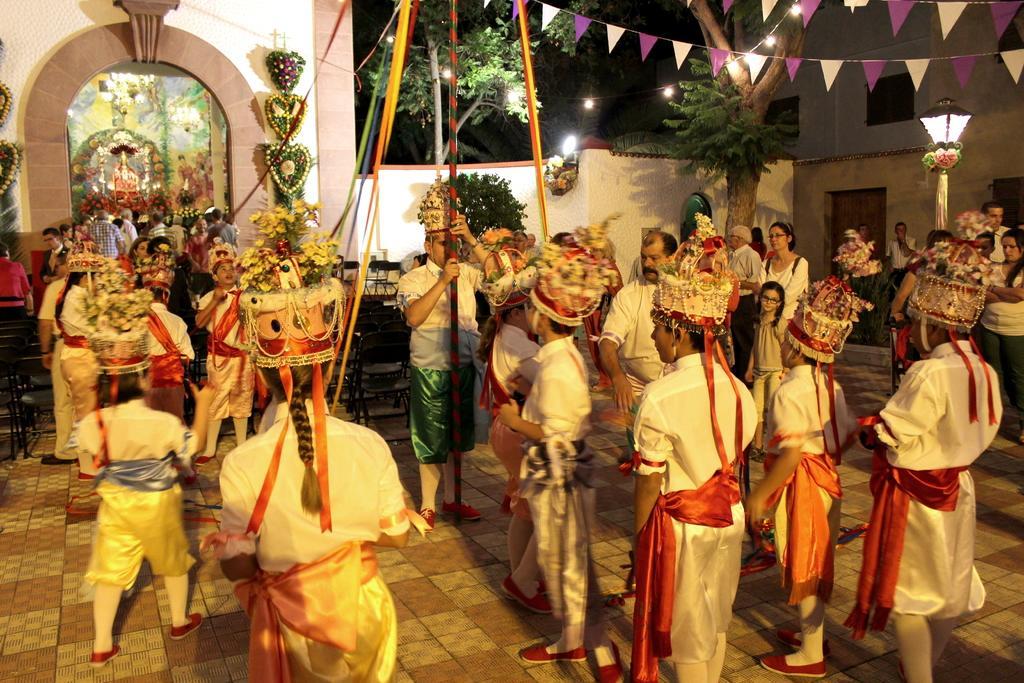In one or two sentences, can you explain what this image depicts? In the foreground of this image, in the middle, there is a man standing and holding a pole and there are persons surrounding him by holding flags. In the background, there is a sculpture, lights, wall, an arch, few trees, bunting flags, lamp and the crowd on the right. 